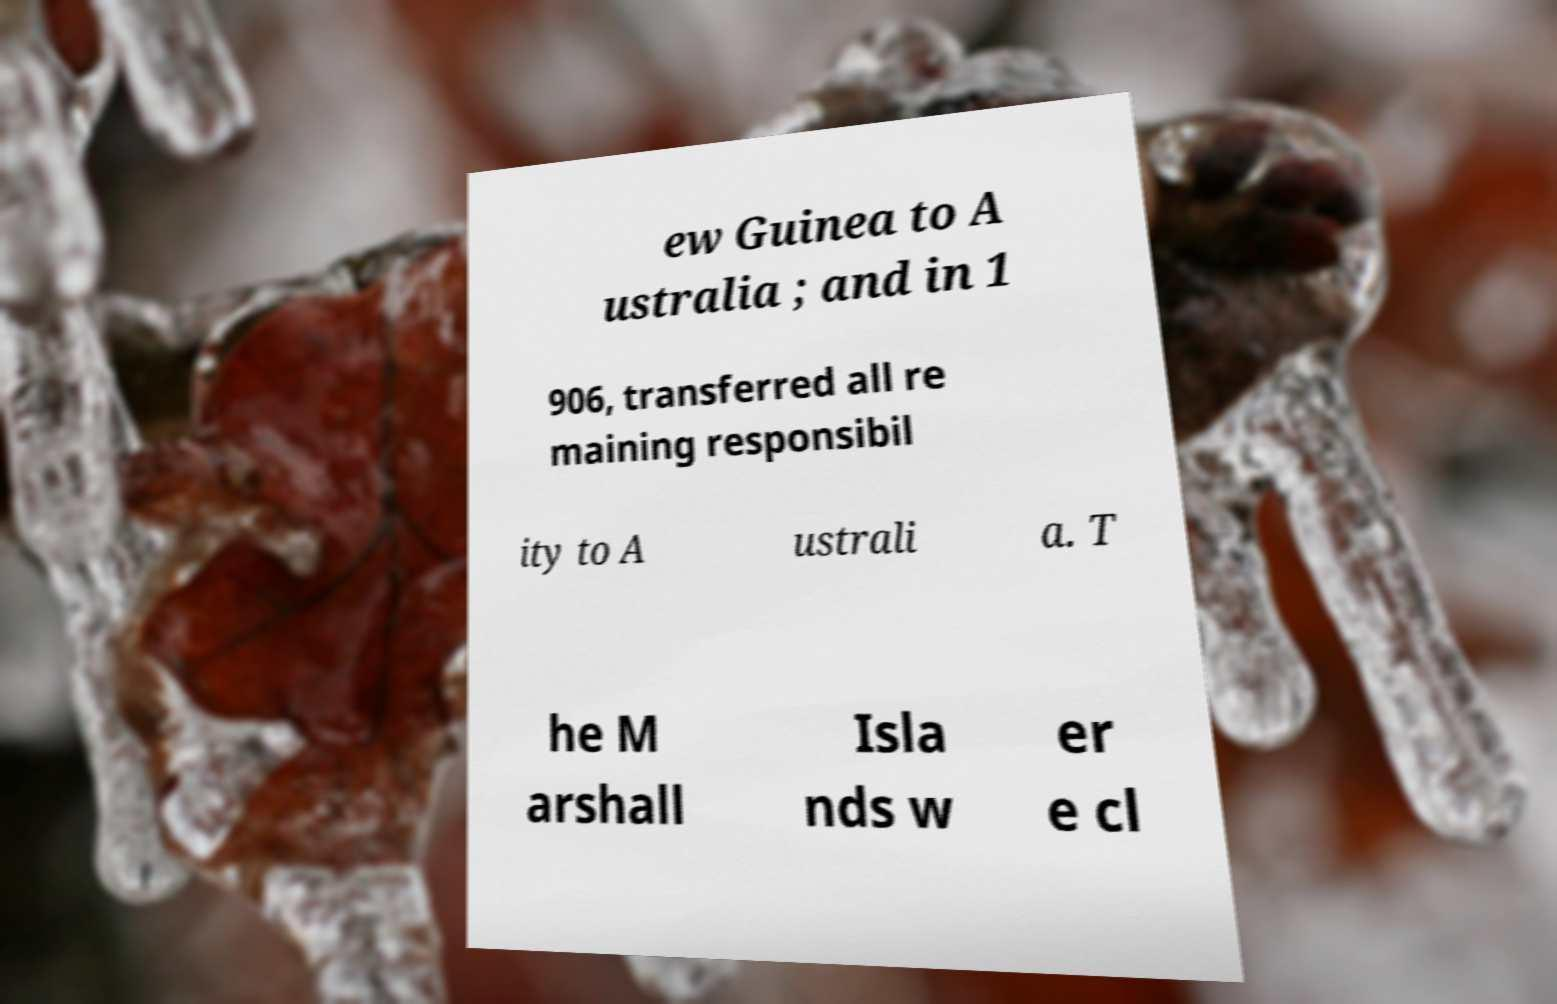Please read and relay the text visible in this image. What does it say? ew Guinea to A ustralia ; and in 1 906, transferred all re maining responsibil ity to A ustrali a. T he M arshall Isla nds w er e cl 